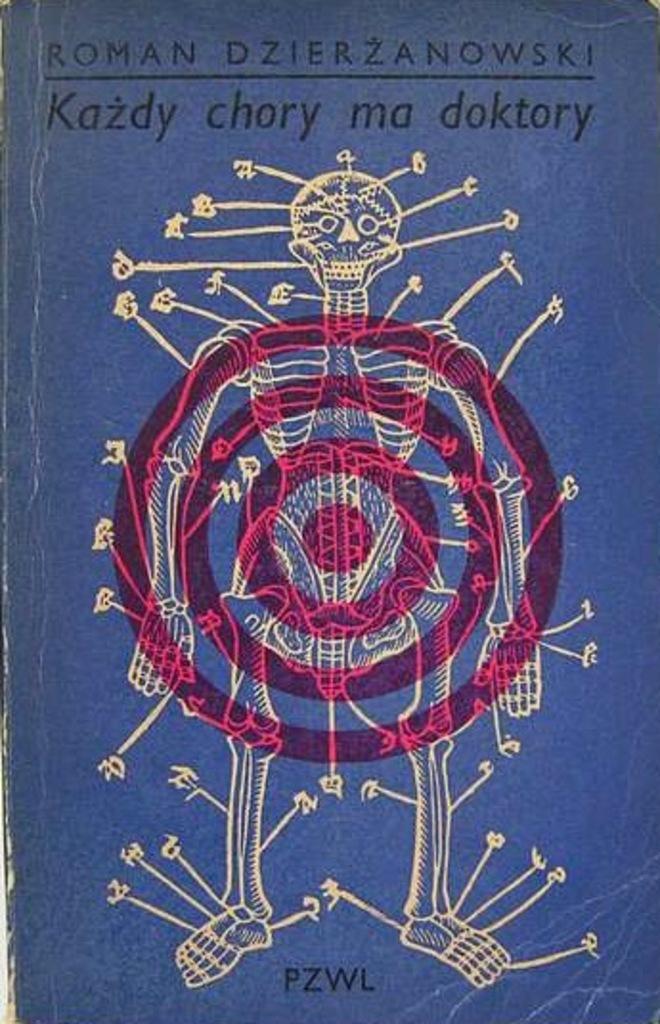Can you describe this image briefly? In this image there is a skeleton and there are some texts written on the image which is blue in colour. 